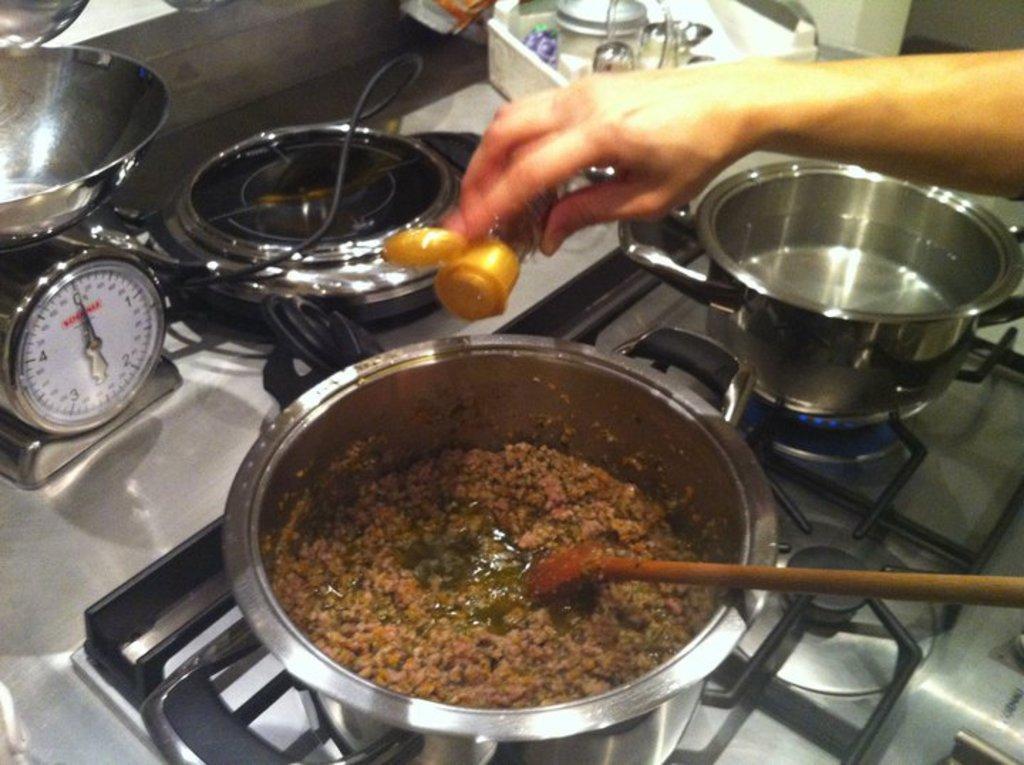Could you give a brief overview of what you see in this image? In this image we can see a person holding a bottle, there is a foot item and a spoon in a bowl, and some water in another bowl, which are kept on the stove, also we can see a stopwatch, pans, bowls, trays, and an electrical instrument. 